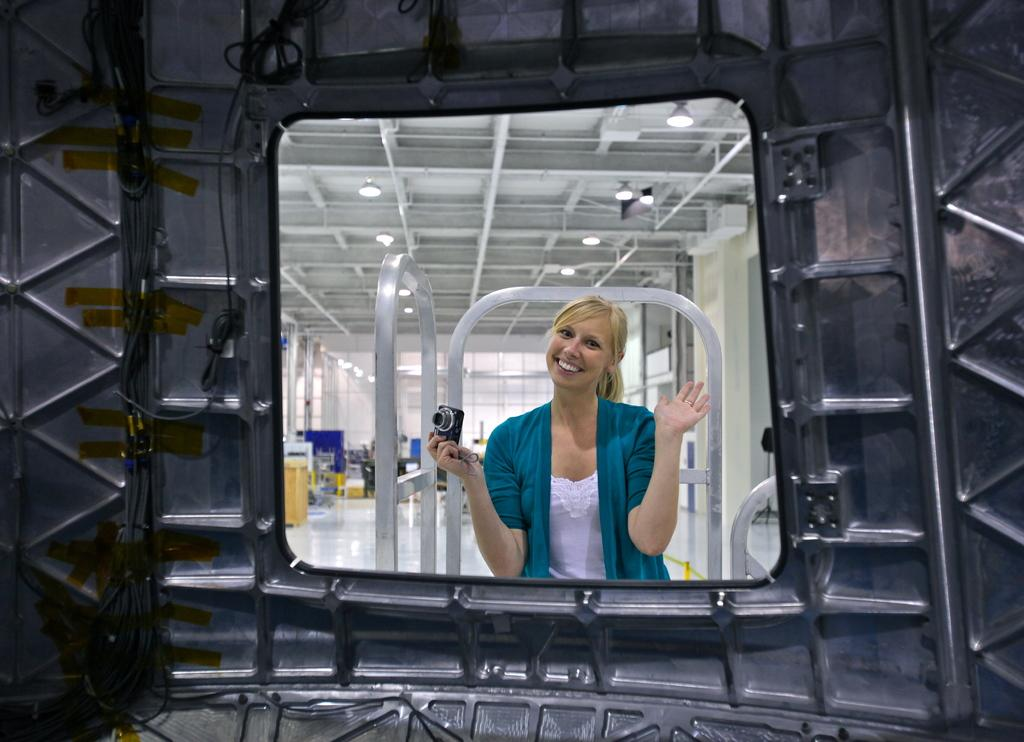Who is present in the image? There is a woman in the image. What is the woman wearing? The woman is wearing a jacket. What is the woman holding in her hand? The woman is holding a camera in her hand. What can be seen in the background of the image? There is a metal wall in the image. What is the lighting situation in the room? Lights are attached to the roof. Can you describe any other objects in the room? There are objects in the room, but their specific details are not mentioned in the facts. What type of wound can be seen on the woman's arm in the image? There is no wound visible on the woman's arm in the image. What is the woman looking at in the image? The facts do not mention what the woman is looking at, so we cannot determine her focus in the image. 